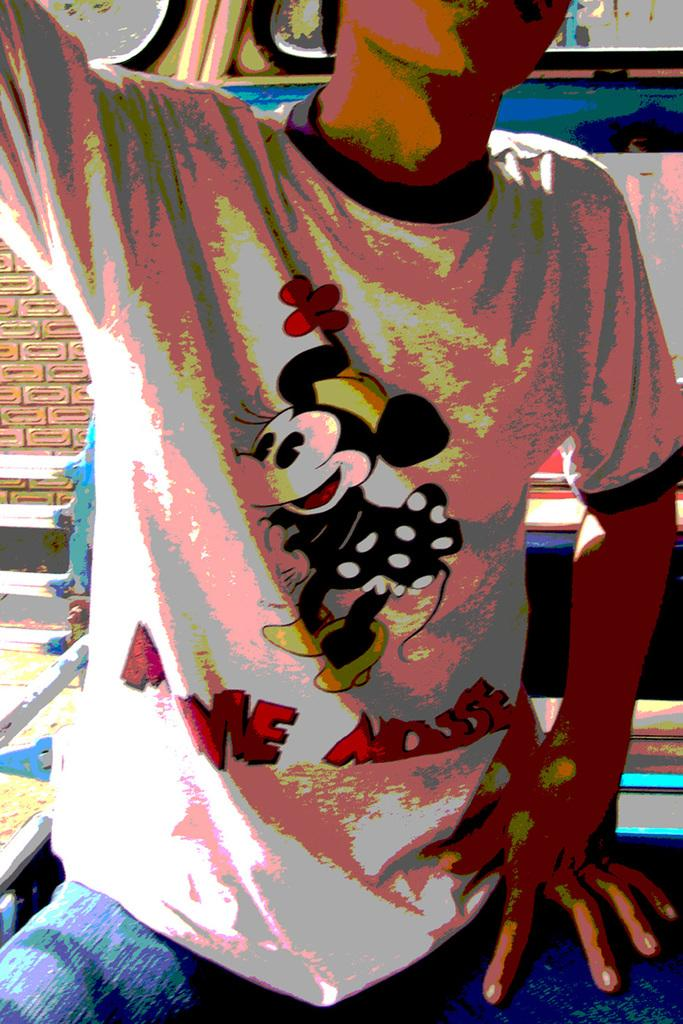Who is present in the image? There is a man in the image. What can be seen in the background of the image? There is a wall in the background of the image. What level of profit does the man achieve in the image? There is no information about profit in the image, as it only features a man and a wall in the background. 